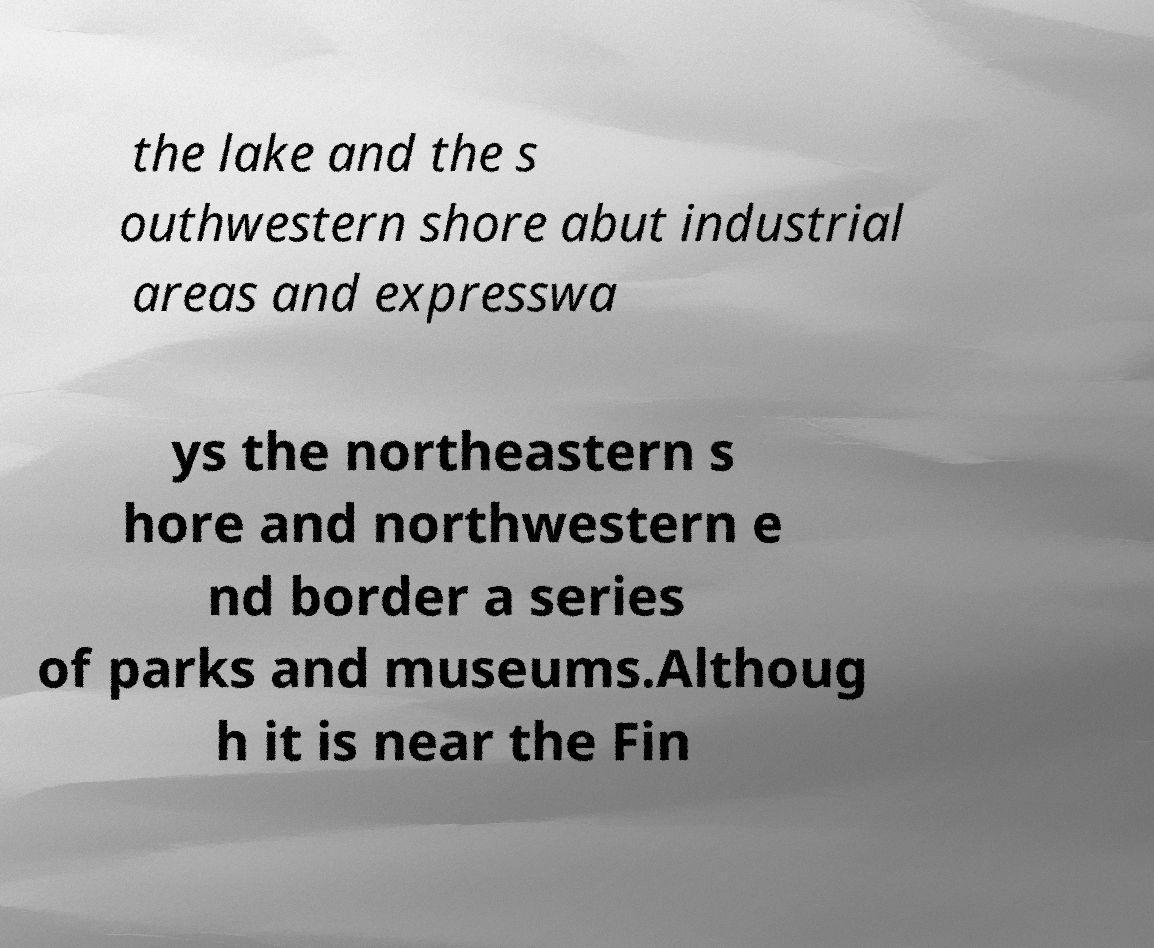Please identify and transcribe the text found in this image. the lake and the s outhwestern shore abut industrial areas and expresswa ys the northeastern s hore and northwestern e nd border a series of parks and museums.Althoug h it is near the Fin 